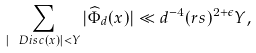Convert formula to latex. <formula><loc_0><loc_0><loc_500><loc_500>\sum _ { | \ D i s c ( x ) | < Y } | \widehat { \Phi } _ { d } ( x ) | \ll d ^ { - 4 } ( r s ) ^ { 2 + \epsilon } Y ,</formula> 